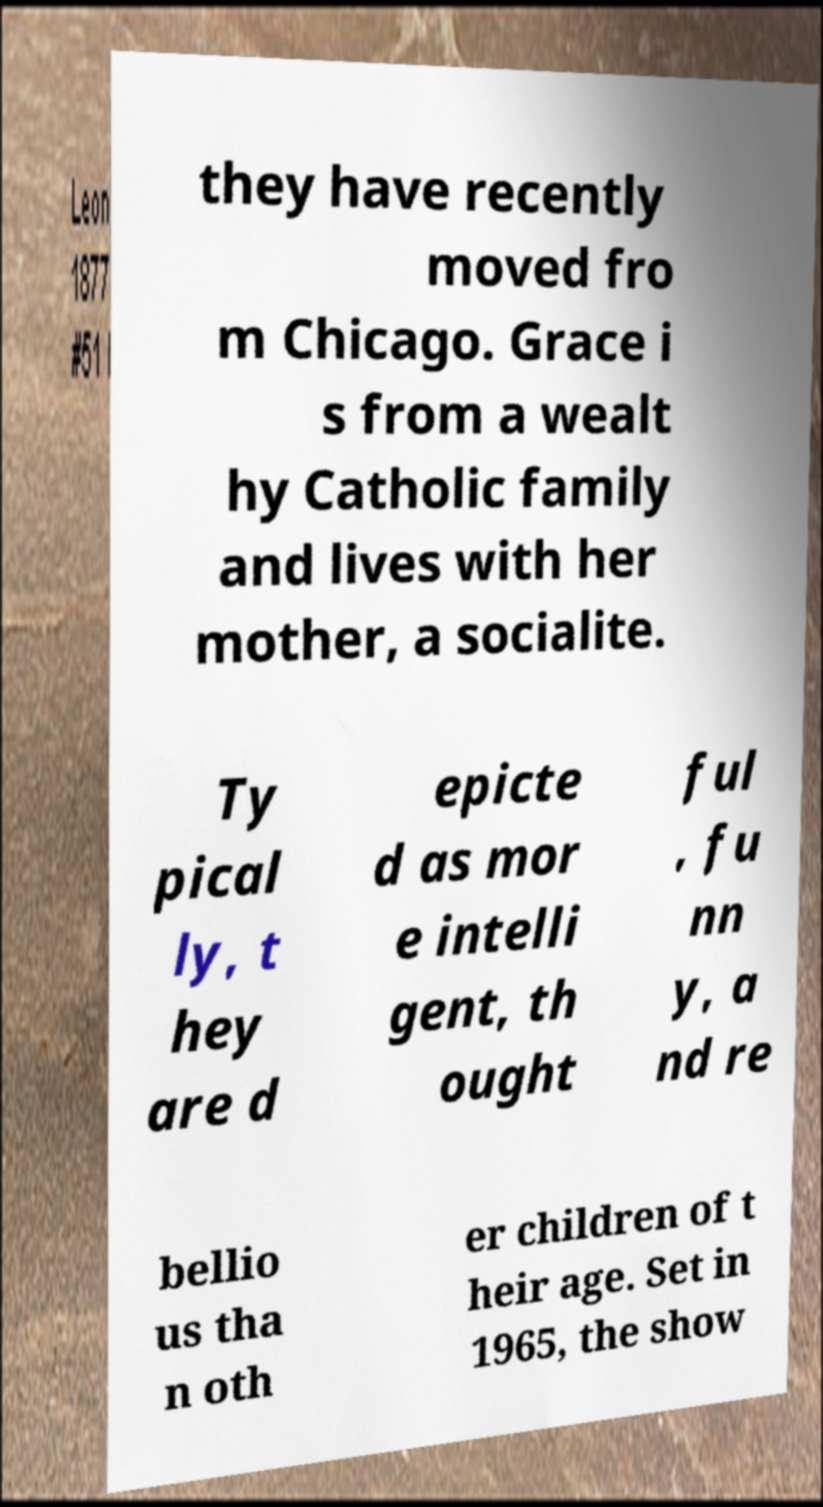Could you assist in decoding the text presented in this image and type it out clearly? they have recently moved fro m Chicago. Grace i s from a wealt hy Catholic family and lives with her mother, a socialite. Ty pical ly, t hey are d epicte d as mor e intelli gent, th ought ful , fu nn y, a nd re bellio us tha n oth er children of t heir age. Set in 1965, the show 